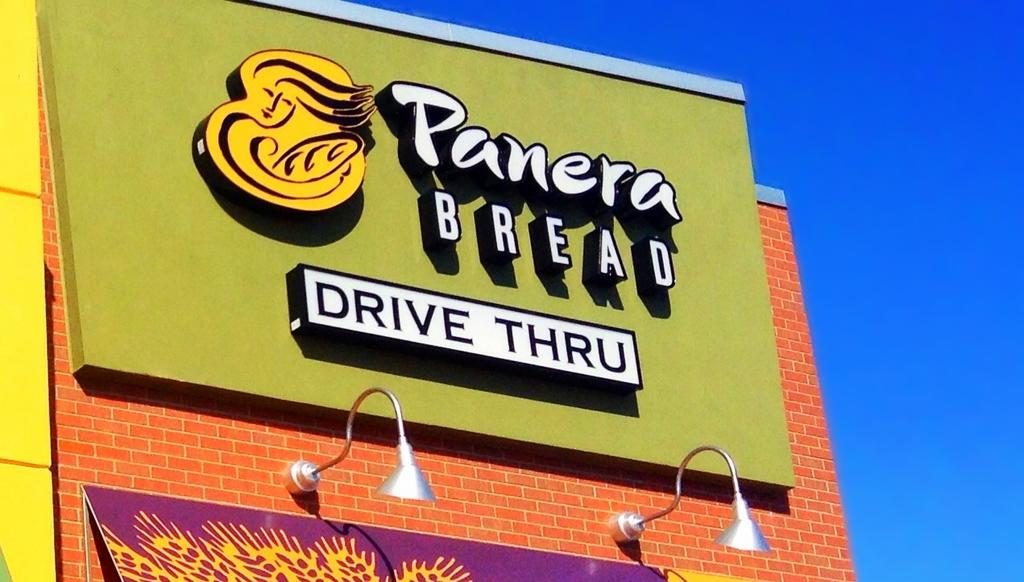<image>
Create a compact narrative representing the image presented. sign for panera bread drive thru above lights on colorful building 